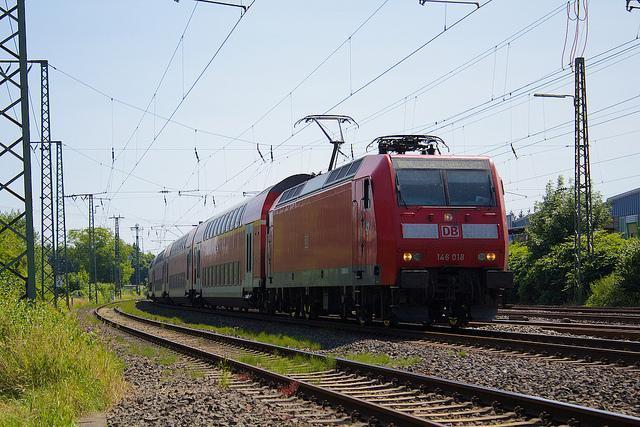How many people are wearing glasses?
Give a very brief answer. 0. 